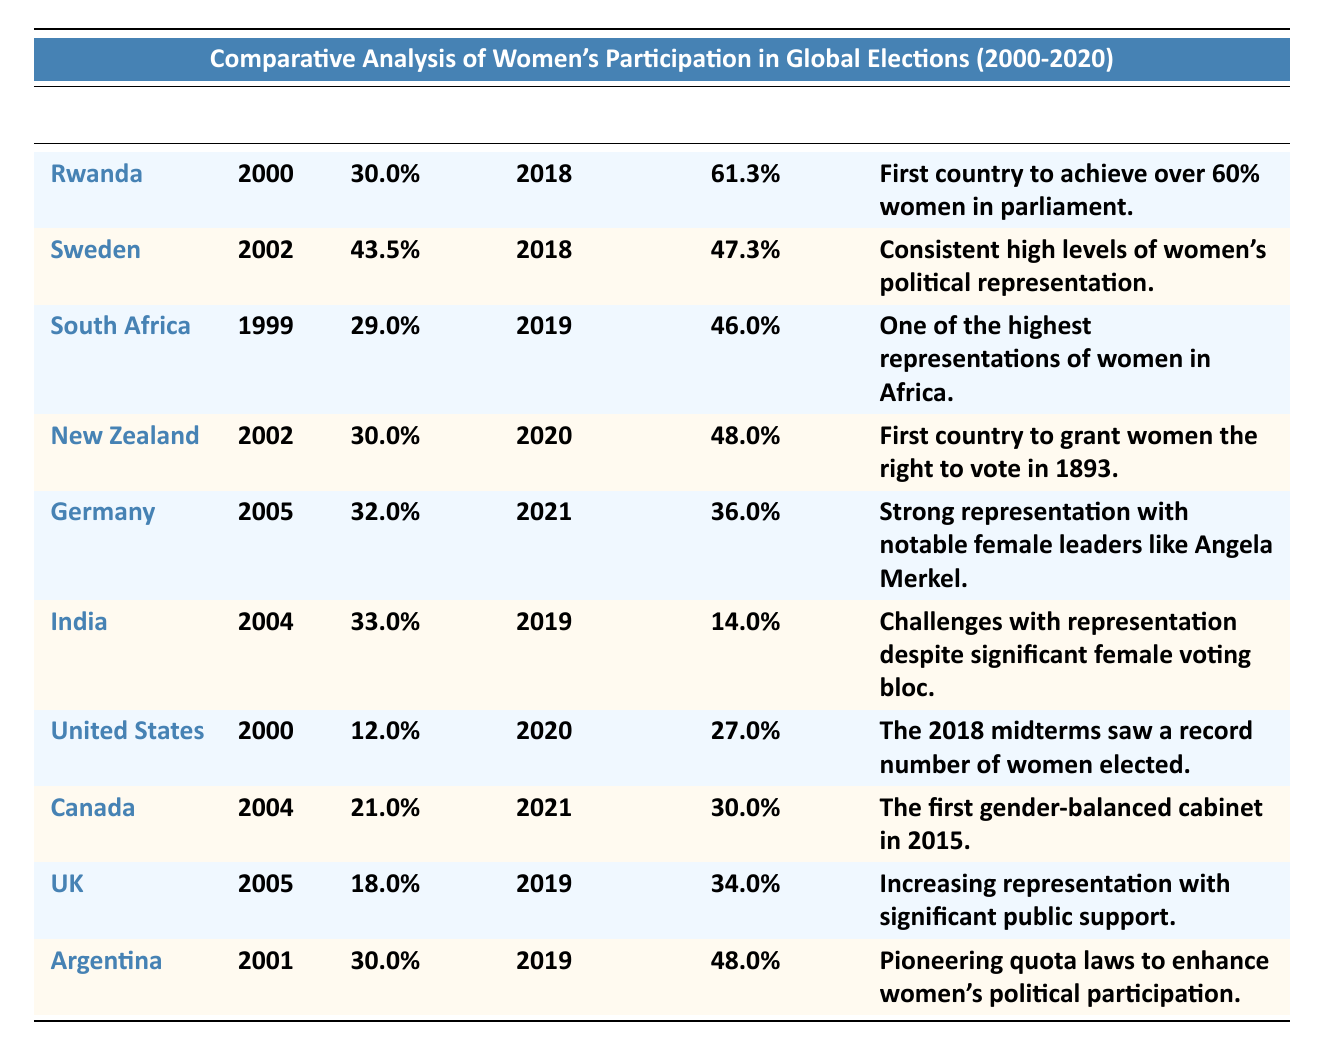What was the percentage of women in parliament in Rwanda in 2000? The table lists Rwanda as having a women percentage in parliament of 30.0% in the year 2000.
Answer: 30.0% What notable achievement is associated with Sweden in regard to women's political representation? The table highlights that Sweden has consistent high levels of women's political representation as a notable achievement.
Answer: Consistent high levels of women's political representation Which country has the highest percentage of women in parliament in the recent elections (2019 or 2020)? By comparing the recent women percentages, Rwanda has 61.3%, which is the highest among all listed countries for recent elections.
Answer: Rwanda (61.3%) What is the difference between the women percentage in parliament in South Africa in 1999 and in 2019? In 1999, the percentage was 29.0% and in 2019, it was 46.0%. The difference is 46.0% - 29.0% = 17.0%.
Answer: 17.0% Did the United States see an increase or decrease in the percentage of women in parliament from 2000 to 2020? The percentage increased from 12.0% in 2000 to 27.0% in 2020, indicating an increase.
Answer: Increase What was the percentage of women in parliament in India in 2019 compared to 2004? India had 33.0% in 2004 and dropped to 14.0% in 2019. This indicates a decrease in the percentage of women in parliament.
Answer: Decrease Which country listed achieved over 60% representation of women in parliament while being the first to do so? Rwanda is noted as the first country to achieve over 60% women in parliament, achieving 61.3% in 2018.
Answer: Rwanda What country has the highest recent percentage of women in parliament from the table, and what year did this occur? Rwanda had the highest recent women percentage of 61.3% in the year 2018, according to the table.
Answer: Rwanda (2018, 61.3%) How does Argentina's recent women percentage compare to that of New Zealand's recent percentage? Argentina has 48.0% in 2019, while New Zealand has 48.0% in 2020. They are equal in recent percentages.
Answer: Equal (48.0%) Is it true that Canada had a gender-balanced cabinet in 2015, and what was the women percentage in parliament in 2021? Yes, it is true that Canada formed the first gender-balanced cabinet in 2015, and in 2021 the women percentage in parliament was 30.0%.
Answer: Yes, 30.0% 